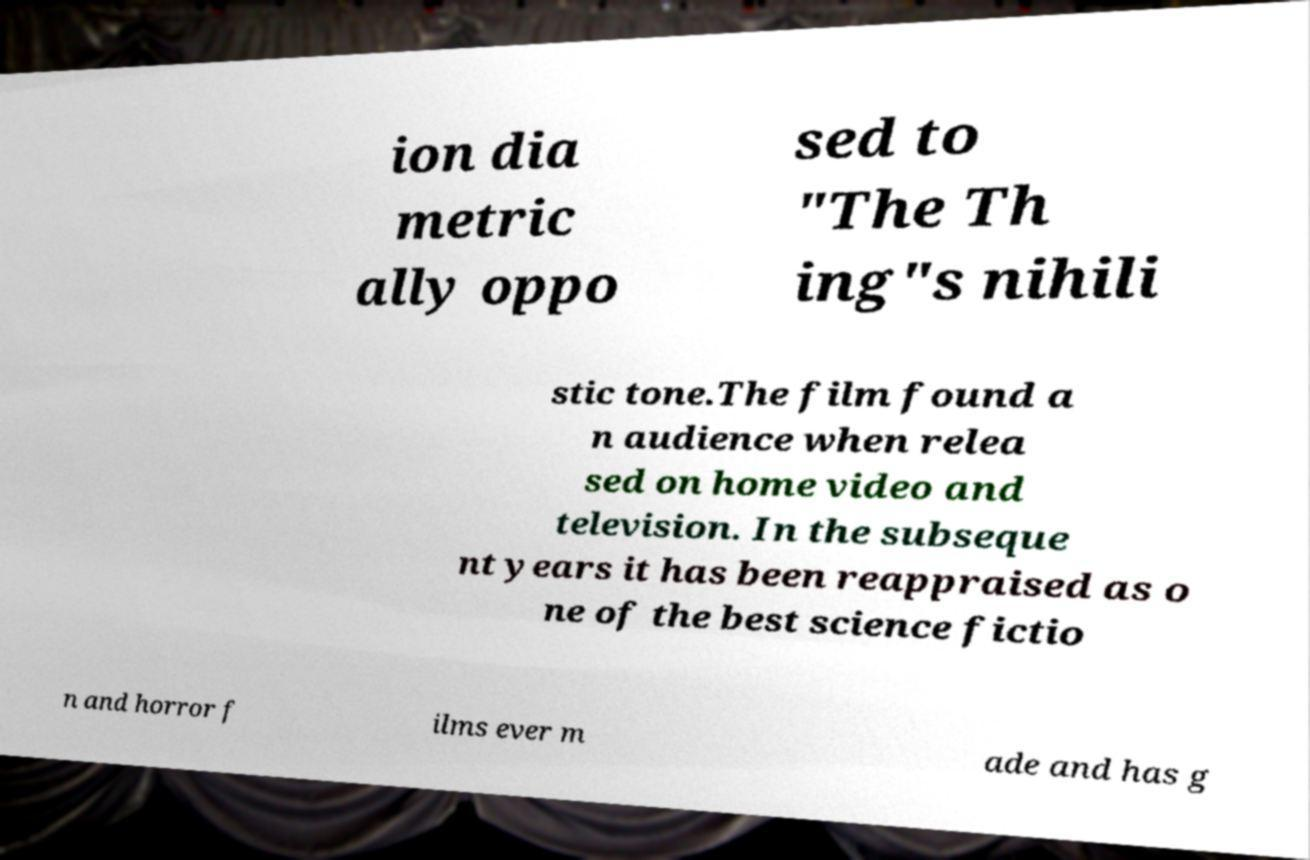Can you read and provide the text displayed in the image?This photo seems to have some interesting text. Can you extract and type it out for me? ion dia metric ally oppo sed to "The Th ing"s nihili stic tone.The film found a n audience when relea sed on home video and television. In the subseque nt years it has been reappraised as o ne of the best science fictio n and horror f ilms ever m ade and has g 